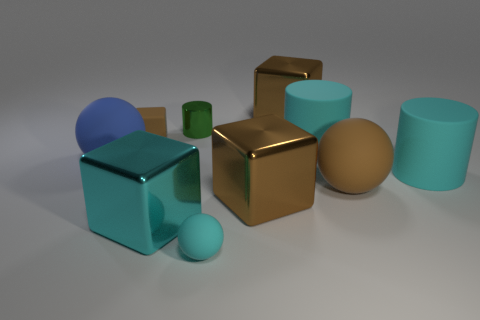Is the blue rubber thing the same shape as the tiny shiny object?
Ensure brevity in your answer.  No. Is the number of small green things right of the large brown rubber sphere the same as the number of large metallic objects that are behind the tiny matte sphere?
Make the answer very short. No. How many other things are there of the same material as the tiny cyan object?
Give a very brief answer. 5. How many large things are either shiny cylinders or metal blocks?
Provide a succinct answer. 3. Are there the same number of tiny green cylinders right of the tiny green metal cylinder and large brown rubber balls?
Give a very brief answer. No. Are there any large brown metal blocks that are right of the big rubber ball right of the cyan metal thing?
Provide a succinct answer. No. How many other things are the same color as the small shiny cylinder?
Your answer should be very brief. 0. The small sphere is what color?
Ensure brevity in your answer.  Cyan. How big is the matte ball that is both to the right of the small brown rubber block and behind the cyan shiny block?
Your response must be concise. Large. How many objects are either small matte objects behind the blue sphere or cyan blocks?
Ensure brevity in your answer.  2. 